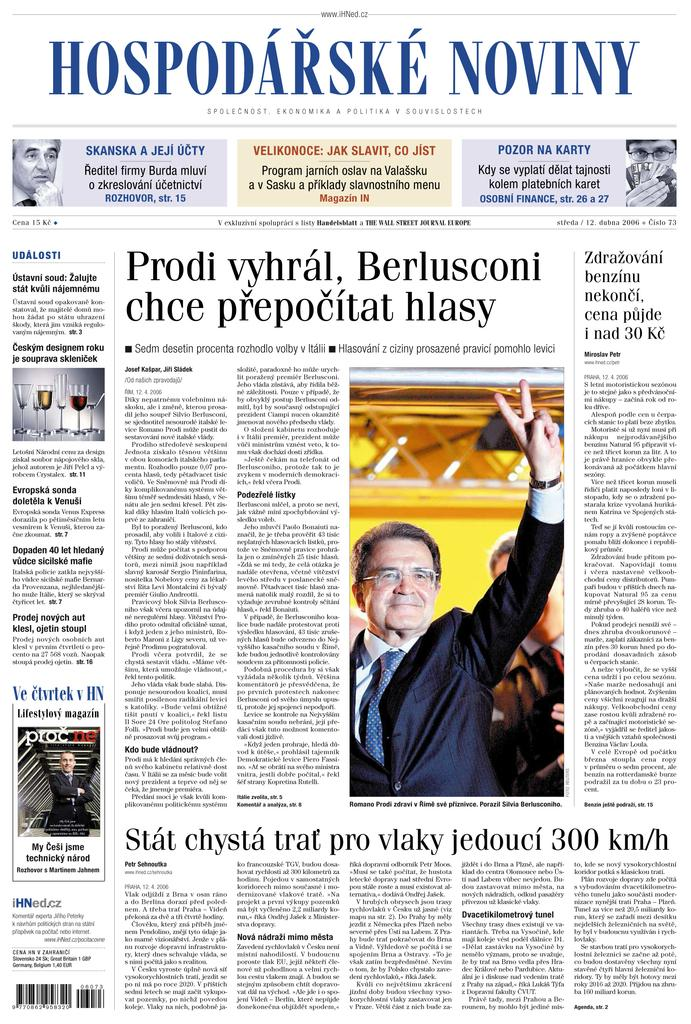What type of print media is depicted in the image? The image is a newspaper. What can be found on the newspaper besides text? There are images on the newspaper. What is the primary form of communication on the newspaper? There is text written on the newspaper. What type of berry is being advertised on the newspaper? There is no berry being advertised on the newspaper; the image only shows a newspaper with images and text. 